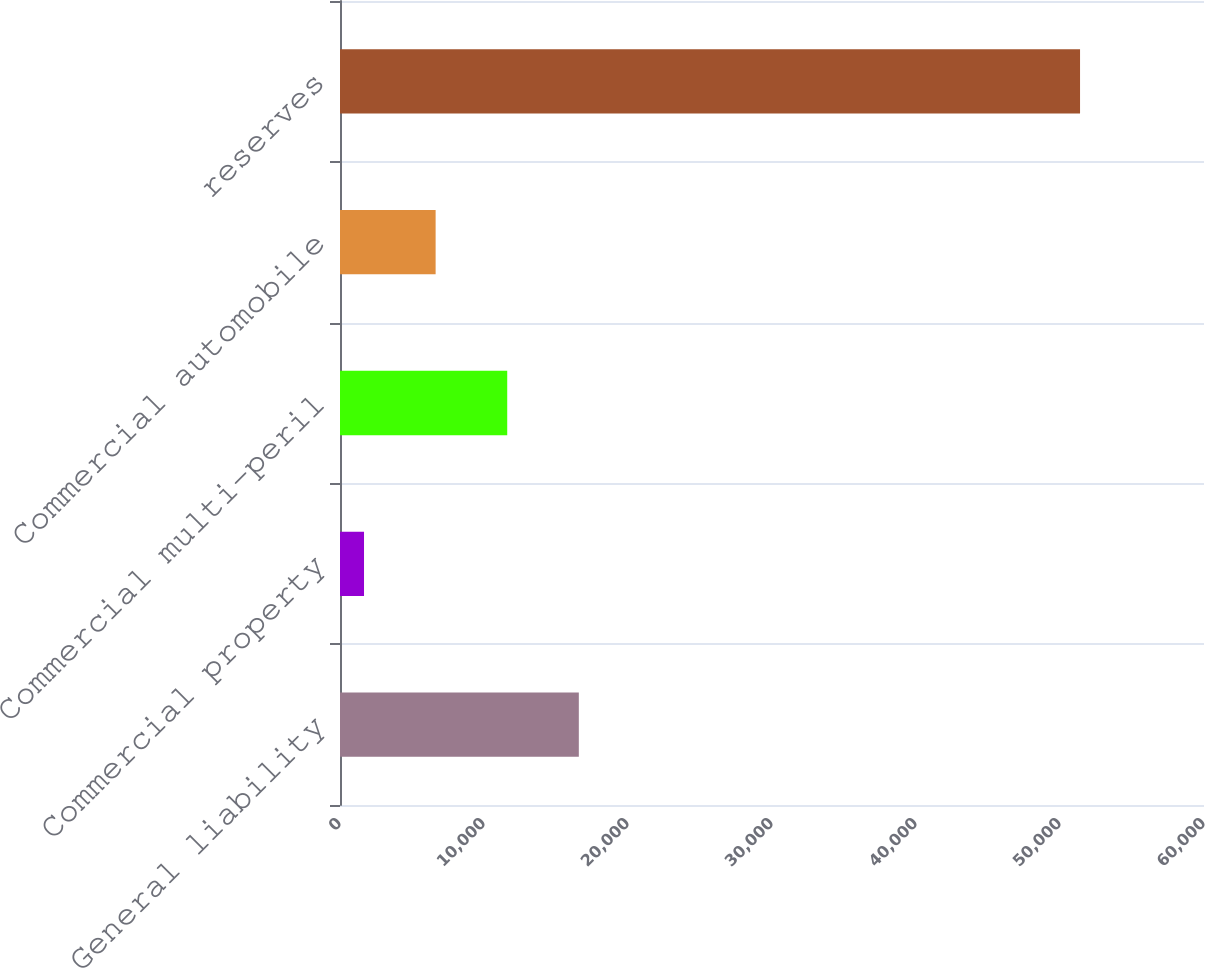Convert chart to OTSL. <chart><loc_0><loc_0><loc_500><loc_500><bar_chart><fcel>General liability<fcel>Commercial property<fcel>Commercial multi-peril<fcel>Commercial automobile<fcel>reserves<nl><fcel>16585.2<fcel>1668<fcel>11612.8<fcel>6640.4<fcel>51392<nl></chart> 